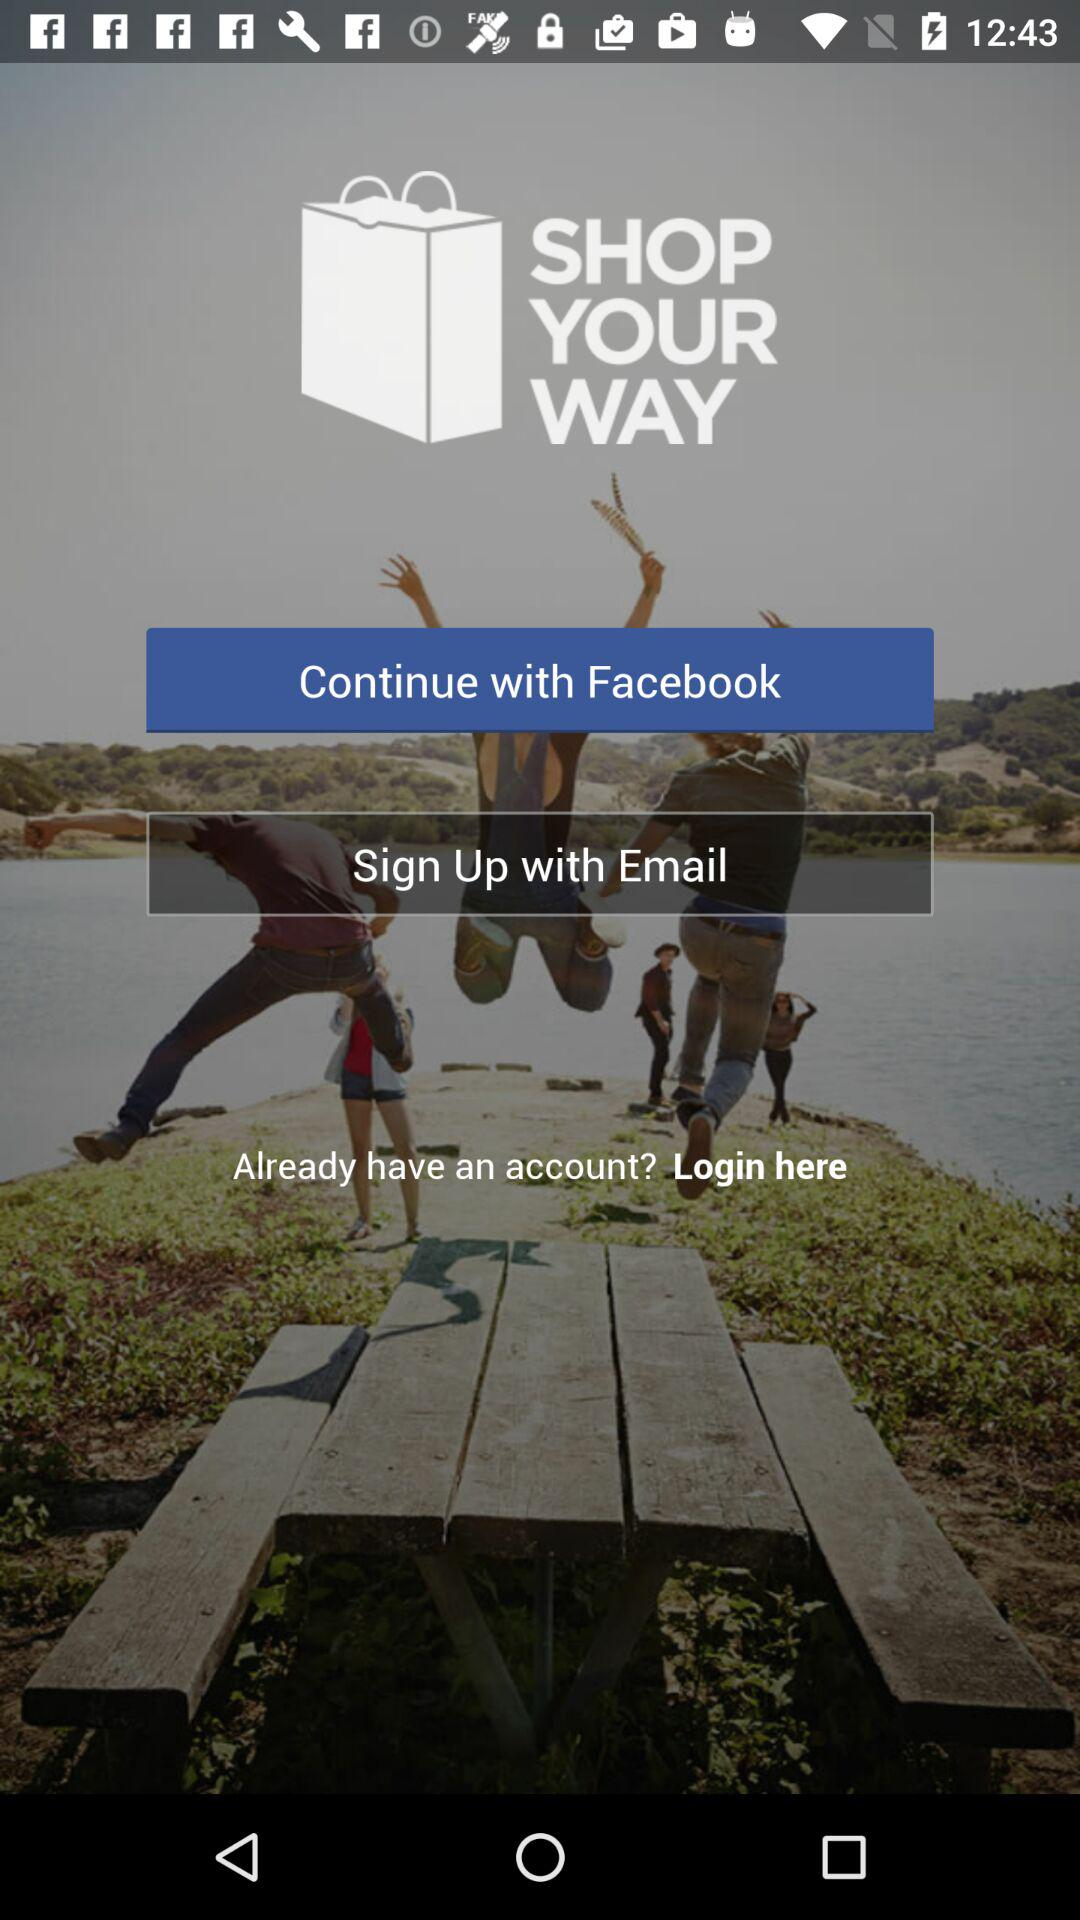How can we sign up? You can sign up with "Facebook" and "Email". 